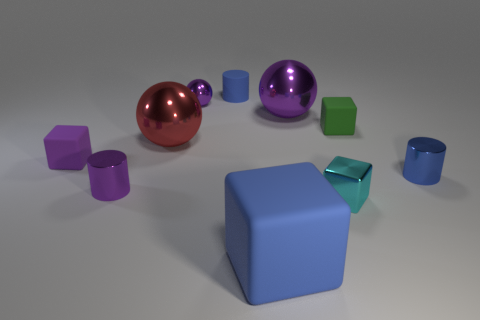Subtract all blue blocks. How many blocks are left? 3 Subtract all gray cubes. Subtract all red cylinders. How many cubes are left? 4 Subtract 0 green spheres. How many objects are left? 10 Subtract all blocks. How many objects are left? 6 Subtract all blue things. Subtract all small brown things. How many objects are left? 7 Add 8 tiny blue rubber objects. How many tiny blue rubber objects are left? 9 Add 4 cyan metallic cubes. How many cyan metallic cubes exist? 5 